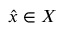<formula> <loc_0><loc_0><loc_500><loc_500>{ \hat { x } } \in X</formula> 